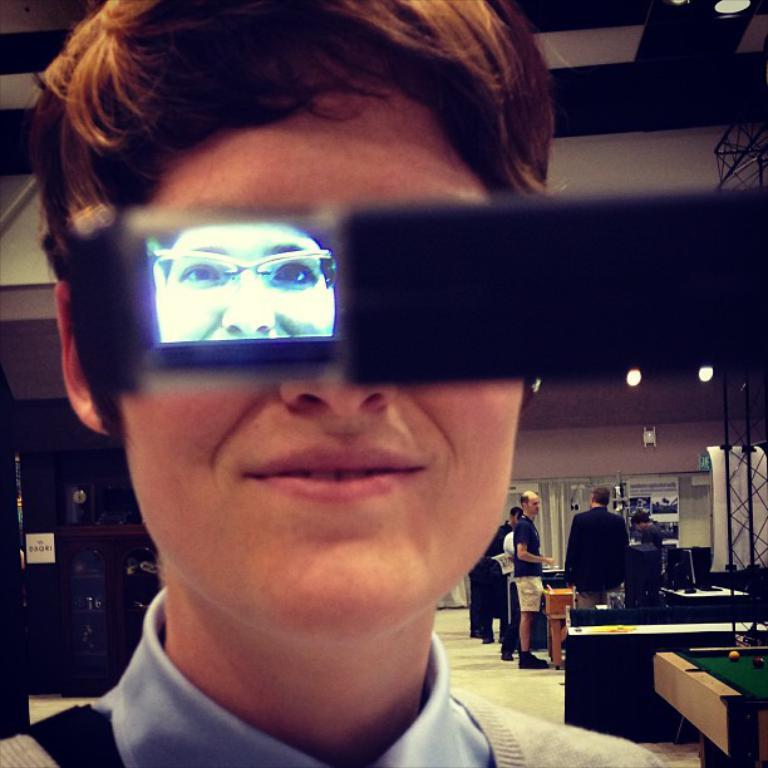How many people are in the image? There is a group of people in the image. Where are the people located in the image? The group of people is standing in the background. What else can be seen in the background of the image? There is a building visible in the background of the image. What color is the blood on the tent in the image? There is no tent or blood present in the image. 